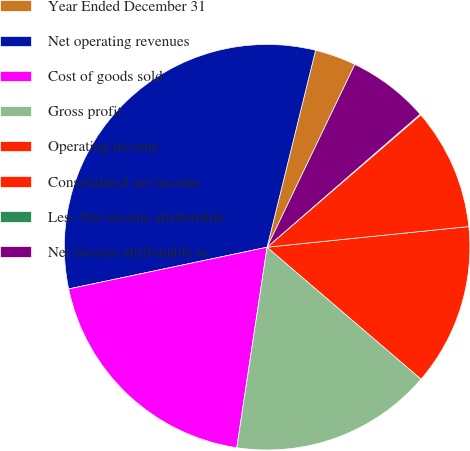Convert chart. <chart><loc_0><loc_0><loc_500><loc_500><pie_chart><fcel>Year Ended December 31<fcel>Net operating revenues<fcel>Cost of goods sold<fcel>Gross profit<fcel>Operating income<fcel>Consolidated net income<fcel>Less Net income attributable<fcel>Net income attributable to<nl><fcel>3.28%<fcel>32.14%<fcel>19.31%<fcel>16.11%<fcel>12.9%<fcel>9.69%<fcel>0.07%<fcel>6.49%<nl></chart> 